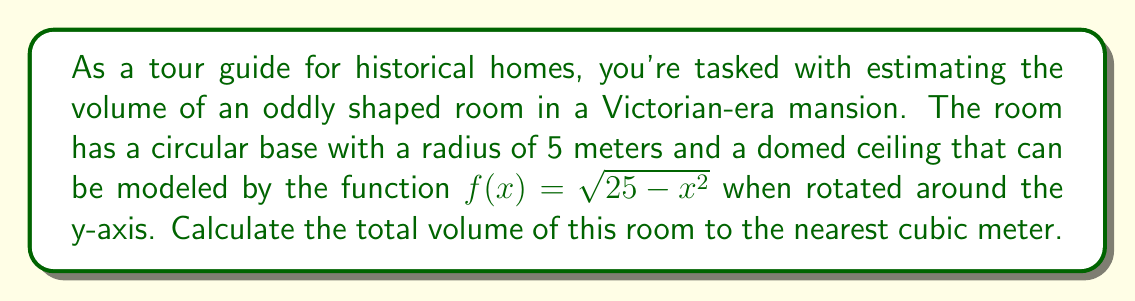Can you solve this math problem? To solve this problem, we need to use the method of volumes by revolution. The room consists of two parts: a cylindrical base and a domed top.

1. Volume of the cylindrical base:
   $$V_{cylinder} = \pi r^2 h$$
   where $r$ is the radius and $h$ is the height. The height of the cylindrical part is equal to the radius (5 meters).
   $$V_{cylinder} = \pi (5^2) (5) = 125\pi$$

2. Volume of the domed top:
   We need to use the washer method to calculate the volume of the dome. The volume is given by:
   $$V_{dome} = \pi \int_0^5 (25 - x^2) dx$$

   To solve this integral:
   $$\begin{align}
   V_{dome} &= \pi \left[25x - \frac{x^3}{3}\right]_0^5 \\
   &= \pi \left[(125 - \frac{125}{3}) - (0 - 0)\right] \\
   &= \pi \left(\frac{250}{3}\right) \\
   &= \frac{250\pi}{3}
   \end{align}$$

3. Total volume:
   $$\begin{align}
   V_{total} &= V_{cylinder} + V_{dome} \\
   &= 125\pi + \frac{250\pi}{3} \\
   &= \frac{375\pi + 250\pi}{3} \\
   &= \frac{625\pi}{3} \\
   &\approx 654.498 \text{ cubic meters}
   \end{align}$$

Rounding to the nearest cubic meter, we get 654 cubic meters.
Answer: 654 cubic meters 